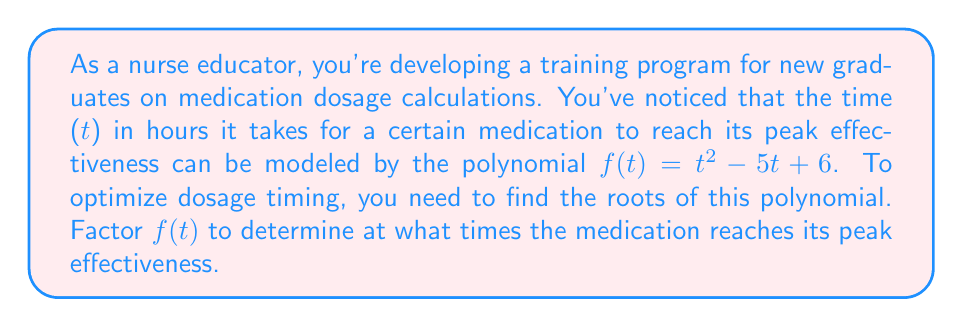Could you help me with this problem? To factor the polynomial $f(t) = t^2 - 5t + 6$, we'll follow these steps:

1) First, identify that this is a quadratic polynomial in the form $at^2 + bt + c$, where $a=1$, $b=-5$, and $c=6$.

2) We'll use the factoring method for quadratic expressions: $(t-r_1)(t-r_2)$, where $r_1$ and $r_2$ are the roots.

3) To find $r_1$ and $r_2$, we need two numbers that:
   - Add up to $-b$ (which is 5 in this case)
   - Multiply to give $ac$ (which is $1 \cdot 6 = 6$ in this case)

4) The numbers that satisfy these conditions are 2 and 3:
   $2 + 3 = 5$
   $2 \cdot 3 = 6$

5) Therefore, we can rewrite the polynomial as:
   $f(t) = t^2 - 5t + 6 = t^2 - 2t - 3t + 6 = t(t-2) - 3(t-2) = (t-2)(t-3)$

6) The factored form is $(t-2)(t-3)$

7) The roots of the polynomial are the values of $t$ that make each factor equal to zero:
   $t - 2 = 0$ or $t - 3 = 0$
   $t = 2$ or $t = 3$

Therefore, the medication reaches its peak effectiveness at 2 hours and 3 hours after administration.
Answer: $(t-2)(t-3)$; peaks at 2 and 3 hours 